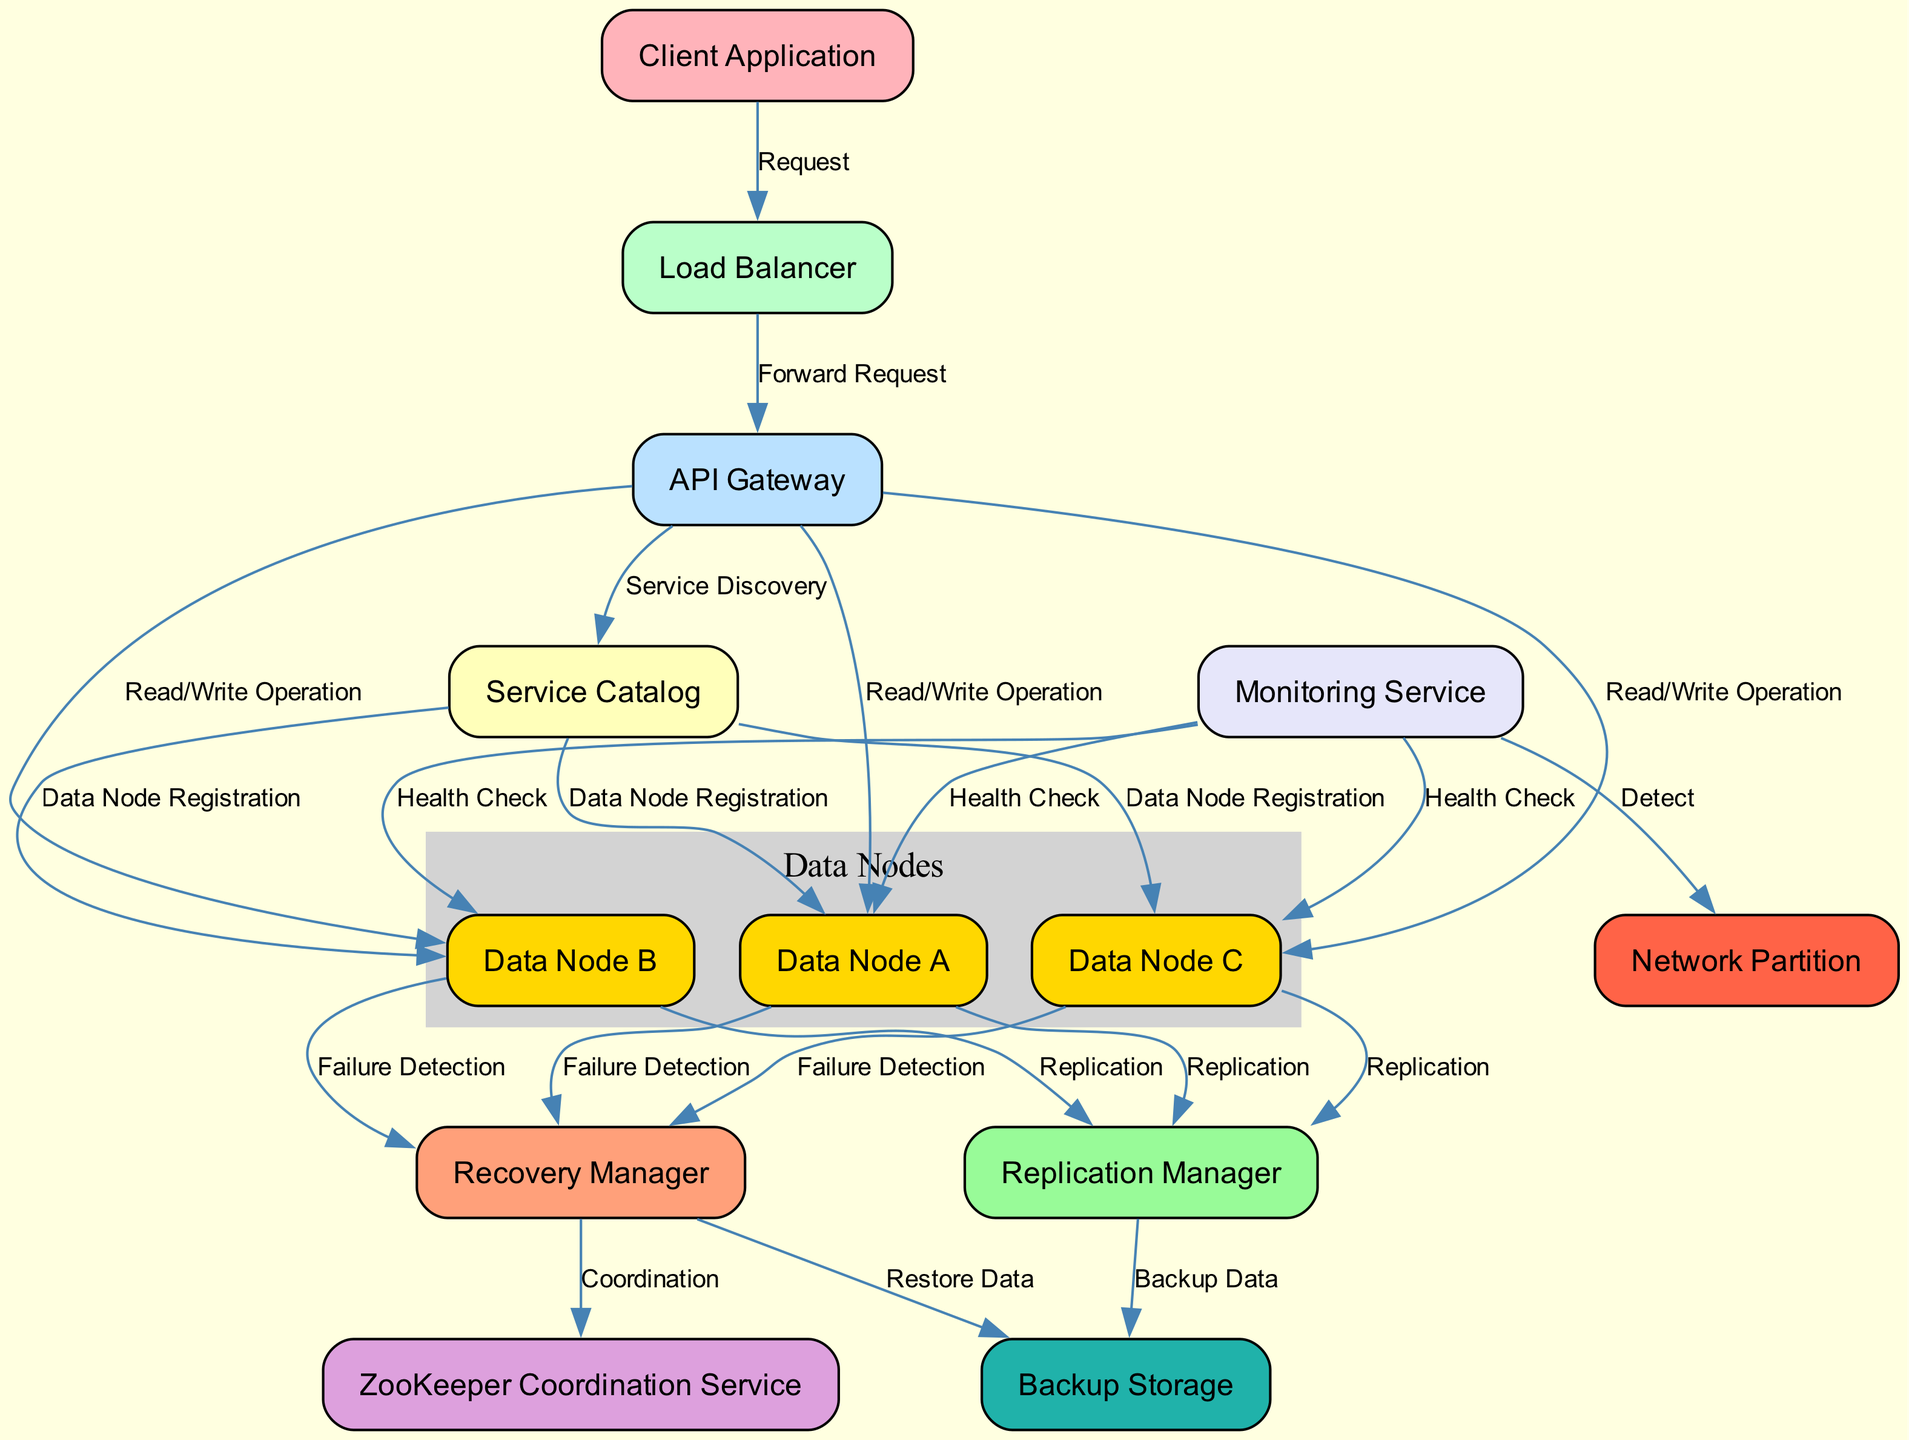What is the initial component that receives requests from the client application? The initial component that interacts with the client application to receive requests is the Load Balancer, as indicated by the directed edge from the Client Application to the Load Balancer.
Answer: Load Balancer How many data nodes are registered in the Service Catalog? The Service Catalog has three connections indicating data node registrations for Data Node A, Data Node B, and Data Node C. Thus, there are three data nodes registered.
Answer: 3 What operation is performed from the API Gateway to the Data Nodes? The operation indicated from the API Gateway to each of the Data Nodes (A, B, C) is Read/Write Operation, which is specified by the edges connecting them.
Answer: Read/Write Operation Which component coordinates the recovery process? The component responsible for the recovery process, as indicated in the diagram, is the Recovery Manager, which has connections leading from the Data Nodes for failure detection.
Answer: Recovery Manager What does the Monitoring Service do to the Data Nodes? The Monitoring Service performs Health Checks on each of the Data Nodes, as shown by the directed edges going to Data Node A, B, and C.
Answer: Health Check Which component stores backup data? The component that stores backup data is the Backup Storage, connected to the Replication Manager, which facilitates backup functionality.
Answer: Backup Storage What is the role of the ZooKeeper Coordination Service in this setup? The ZooKeeper Coordination Service is involved in the coordination of the recovery process, as indicated by the connection from the Recovery Manager to ZooKeeper.
Answer: Coordination In case of a network issue, which component is directly involved with the detection? The component that detects a network partition is the Monitoring Service, which has a direct link to the Network Partition node indicating this functionality.
Answer: Detect 